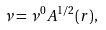Convert formula to latex. <formula><loc_0><loc_0><loc_500><loc_500>\nu = \nu ^ { 0 } A ^ { 1 / 2 } ( r ) ,</formula> 